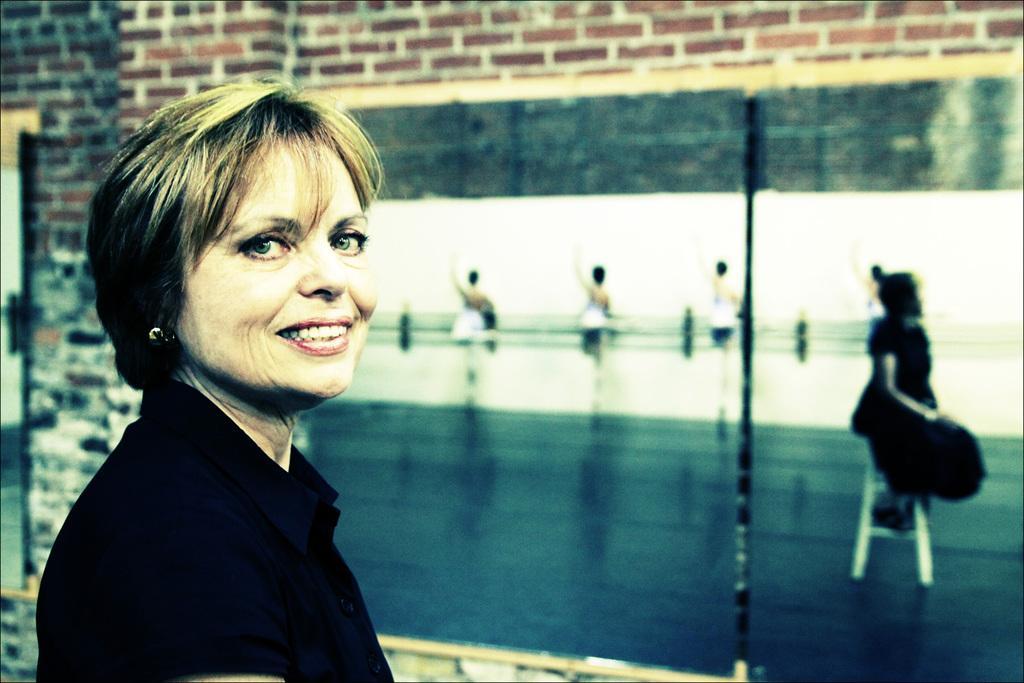How would you summarize this image in a sentence or two? In this image there is a lady standing beside the building on which we can see there is a board with image of people. 